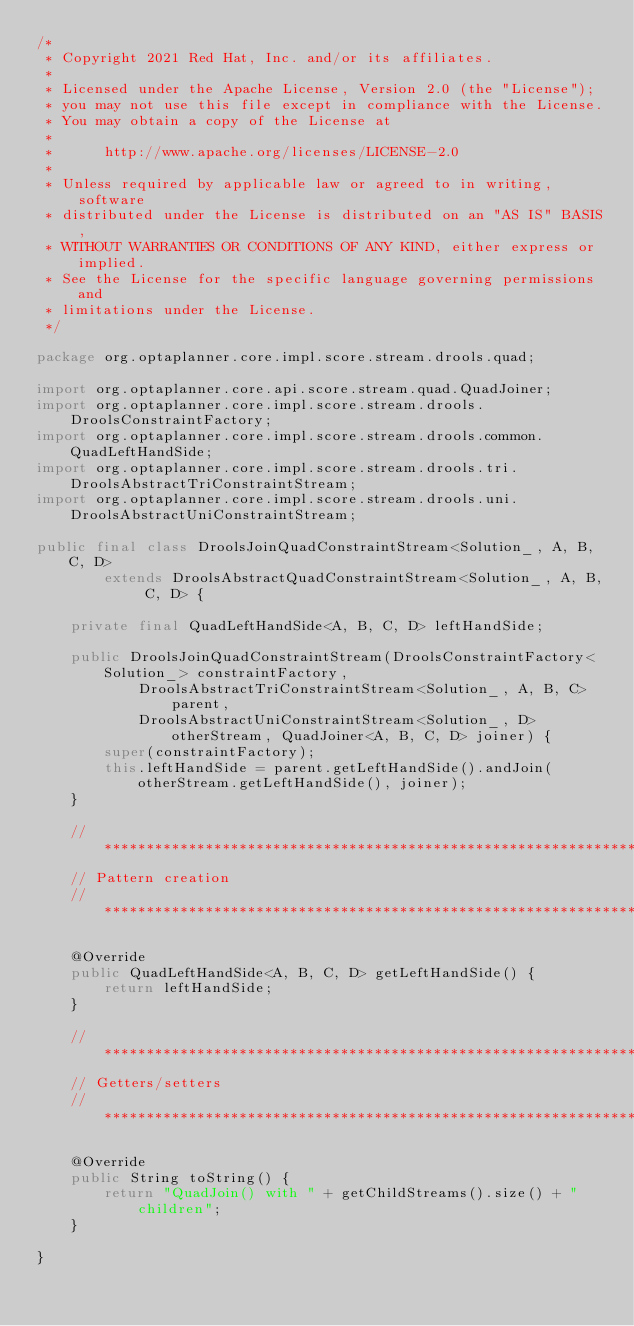<code> <loc_0><loc_0><loc_500><loc_500><_Java_>/*
 * Copyright 2021 Red Hat, Inc. and/or its affiliates.
 *
 * Licensed under the Apache License, Version 2.0 (the "License");
 * you may not use this file except in compliance with the License.
 * You may obtain a copy of the License at
 *
 *      http://www.apache.org/licenses/LICENSE-2.0
 *
 * Unless required by applicable law or agreed to in writing, software
 * distributed under the License is distributed on an "AS IS" BASIS,
 * WITHOUT WARRANTIES OR CONDITIONS OF ANY KIND, either express or implied.
 * See the License for the specific language governing permissions and
 * limitations under the License.
 */

package org.optaplanner.core.impl.score.stream.drools.quad;

import org.optaplanner.core.api.score.stream.quad.QuadJoiner;
import org.optaplanner.core.impl.score.stream.drools.DroolsConstraintFactory;
import org.optaplanner.core.impl.score.stream.drools.common.QuadLeftHandSide;
import org.optaplanner.core.impl.score.stream.drools.tri.DroolsAbstractTriConstraintStream;
import org.optaplanner.core.impl.score.stream.drools.uni.DroolsAbstractUniConstraintStream;

public final class DroolsJoinQuadConstraintStream<Solution_, A, B, C, D>
        extends DroolsAbstractQuadConstraintStream<Solution_, A, B, C, D> {

    private final QuadLeftHandSide<A, B, C, D> leftHandSide;

    public DroolsJoinQuadConstraintStream(DroolsConstraintFactory<Solution_> constraintFactory,
            DroolsAbstractTriConstraintStream<Solution_, A, B, C> parent,
            DroolsAbstractUniConstraintStream<Solution_, D> otherStream, QuadJoiner<A, B, C, D> joiner) {
        super(constraintFactory);
        this.leftHandSide = parent.getLeftHandSide().andJoin(otherStream.getLeftHandSide(), joiner);
    }

    // ************************************************************************
    // Pattern creation
    // ************************************************************************

    @Override
    public QuadLeftHandSide<A, B, C, D> getLeftHandSide() {
        return leftHandSide;
    }

    // ************************************************************************
    // Getters/setters
    // ************************************************************************

    @Override
    public String toString() {
        return "QuadJoin() with " + getChildStreams().size() + " children";
    }

}
</code> 